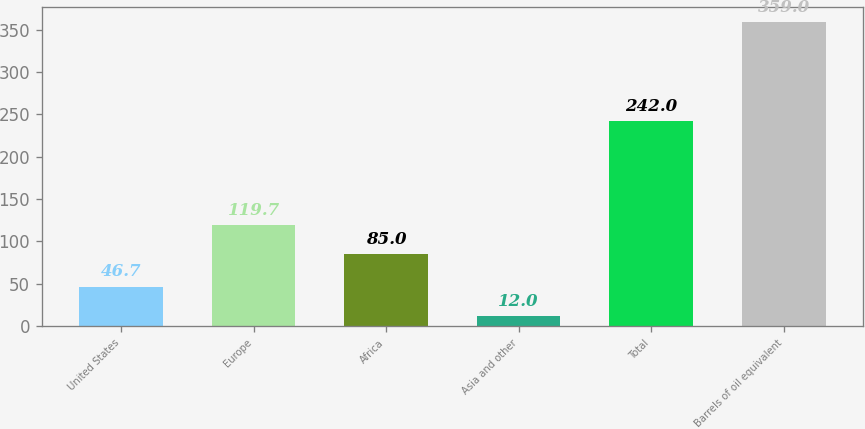<chart> <loc_0><loc_0><loc_500><loc_500><bar_chart><fcel>United States<fcel>Europe<fcel>Africa<fcel>Asia and other<fcel>Total<fcel>Barrels of oil equivalent<nl><fcel>46.7<fcel>119.7<fcel>85<fcel>12<fcel>242<fcel>359<nl></chart> 